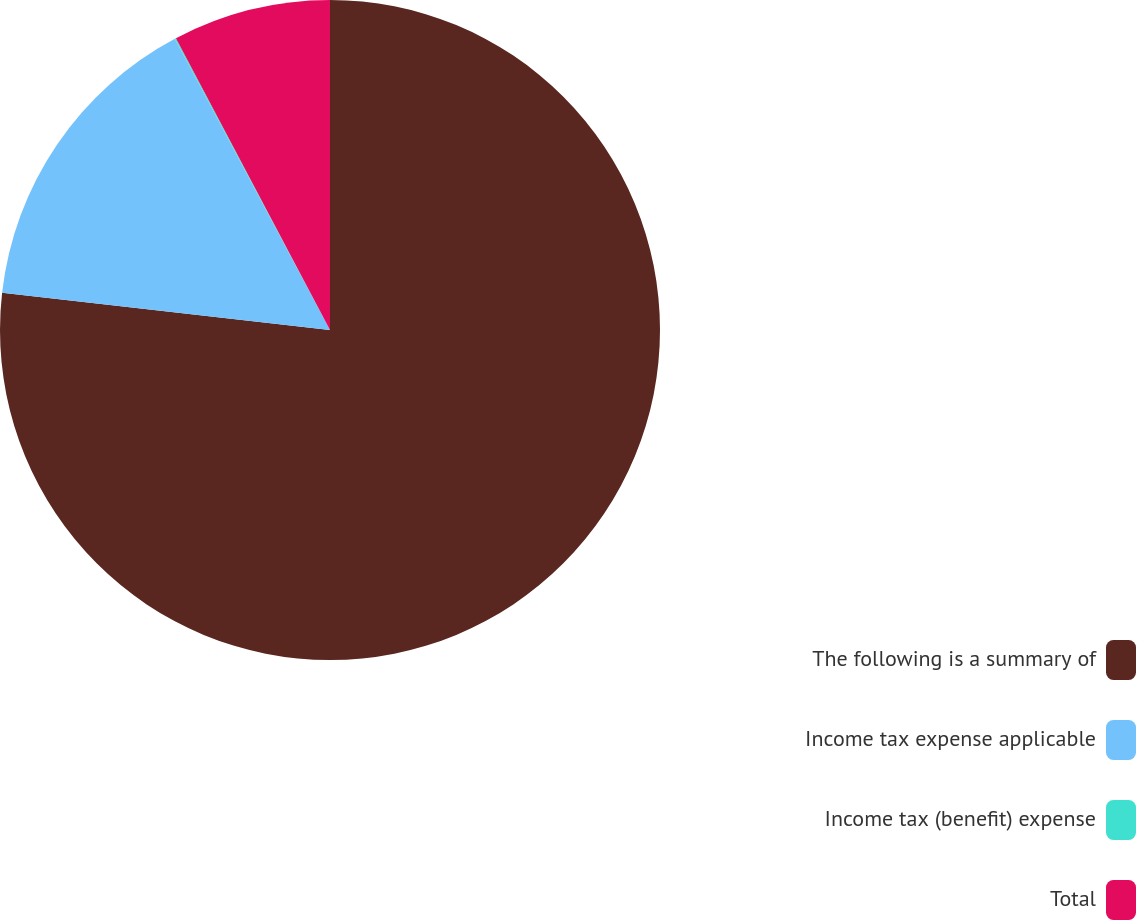Convert chart to OTSL. <chart><loc_0><loc_0><loc_500><loc_500><pie_chart><fcel>The following is a summary of<fcel>Income tax expense applicable<fcel>Income tax (benefit) expense<fcel>Total<nl><fcel>76.8%<fcel>15.41%<fcel>0.06%<fcel>7.73%<nl></chart> 